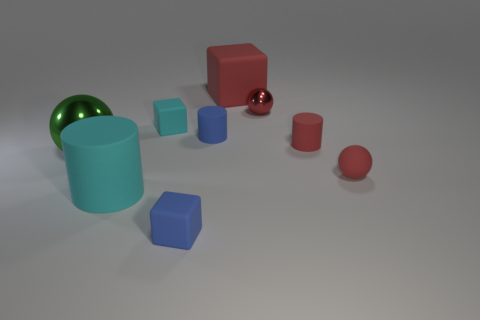Add 1 small blue cylinders. How many objects exist? 10 Subtract all red spheres. How many spheres are left? 1 Subtract all spheres. How many objects are left? 6 Subtract 2 cylinders. How many cylinders are left? 1 Subtract all blue balls. Subtract all red cylinders. How many balls are left? 3 Subtract all blue cylinders. How many yellow blocks are left? 0 Subtract all red metal objects. Subtract all green balls. How many objects are left? 7 Add 9 blue matte cubes. How many blue matte cubes are left? 10 Add 6 large red objects. How many large red objects exist? 7 Subtract all cyan cubes. How many cubes are left? 2 